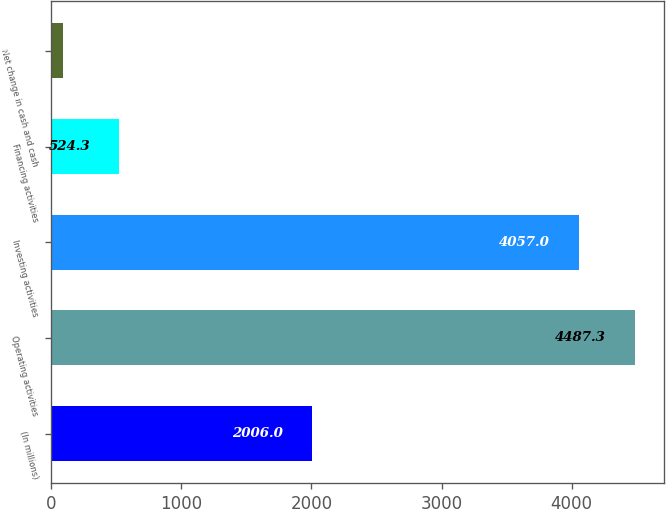Convert chart. <chart><loc_0><loc_0><loc_500><loc_500><bar_chart><fcel>(In millions)<fcel>Operating activities<fcel>Investing activities<fcel>Financing activities<fcel>Net change in cash and cash<nl><fcel>2006<fcel>4487.3<fcel>4057<fcel>524.3<fcel>94<nl></chart> 